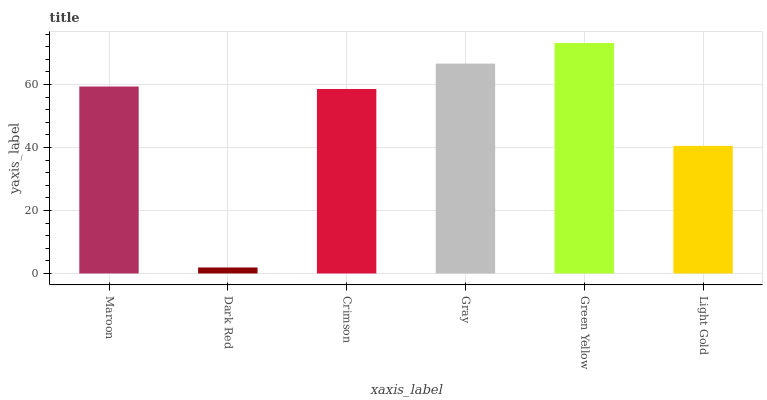Is Crimson the minimum?
Answer yes or no. No. Is Crimson the maximum?
Answer yes or no. No. Is Crimson greater than Dark Red?
Answer yes or no. Yes. Is Dark Red less than Crimson?
Answer yes or no. Yes. Is Dark Red greater than Crimson?
Answer yes or no. No. Is Crimson less than Dark Red?
Answer yes or no. No. Is Maroon the high median?
Answer yes or no. Yes. Is Crimson the low median?
Answer yes or no. Yes. Is Crimson the high median?
Answer yes or no. No. Is Gray the low median?
Answer yes or no. No. 